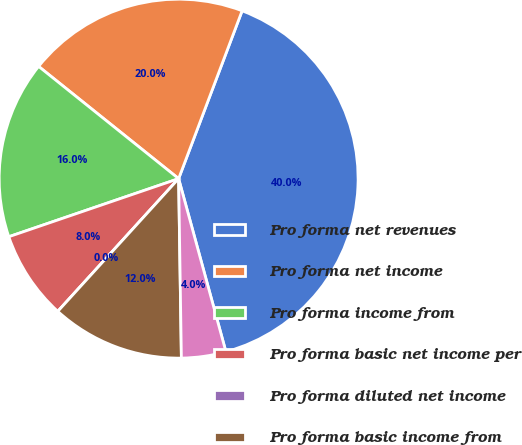Convert chart. <chart><loc_0><loc_0><loc_500><loc_500><pie_chart><fcel>Pro forma net revenues<fcel>Pro forma net income<fcel>Pro forma income from<fcel>Pro forma basic net income per<fcel>Pro forma diluted net income<fcel>Pro forma basic income from<fcel>Pro forma diluted income from<nl><fcel>40.0%<fcel>20.0%<fcel>16.0%<fcel>8.0%<fcel>0.0%<fcel>12.0%<fcel>4.0%<nl></chart> 